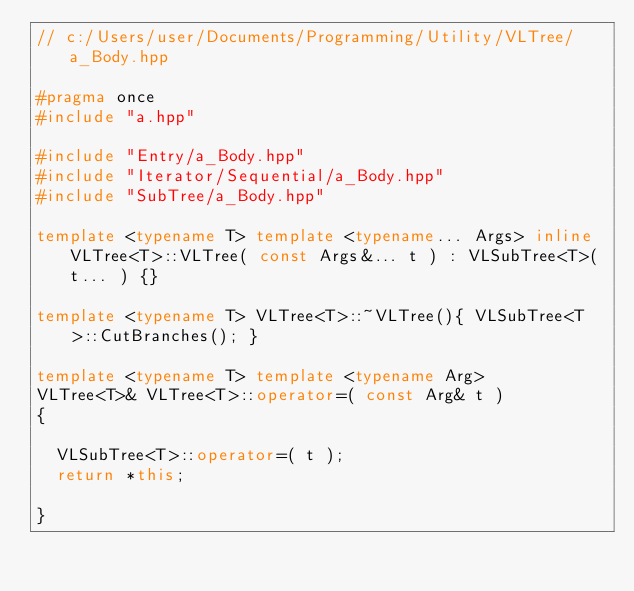<code> <loc_0><loc_0><loc_500><loc_500><_C++_>// c:/Users/user/Documents/Programming/Utility/VLTree/a_Body.hpp

#pragma once
#include "a.hpp"

#include "Entry/a_Body.hpp"
#include "Iterator/Sequential/a_Body.hpp"
#include "SubTree/a_Body.hpp"

template <typename T> template <typename... Args> inline VLTree<T>::VLTree( const Args&... t ) : VLSubTree<T>( t... ) {}

template <typename T> VLTree<T>::~VLTree(){ VLSubTree<T>::CutBranches(); }

template <typename T> template <typename Arg>
VLTree<T>& VLTree<T>::operator=( const Arg& t )
{

  VLSubTree<T>::operator=( t );
  return *this;

}
</code> 